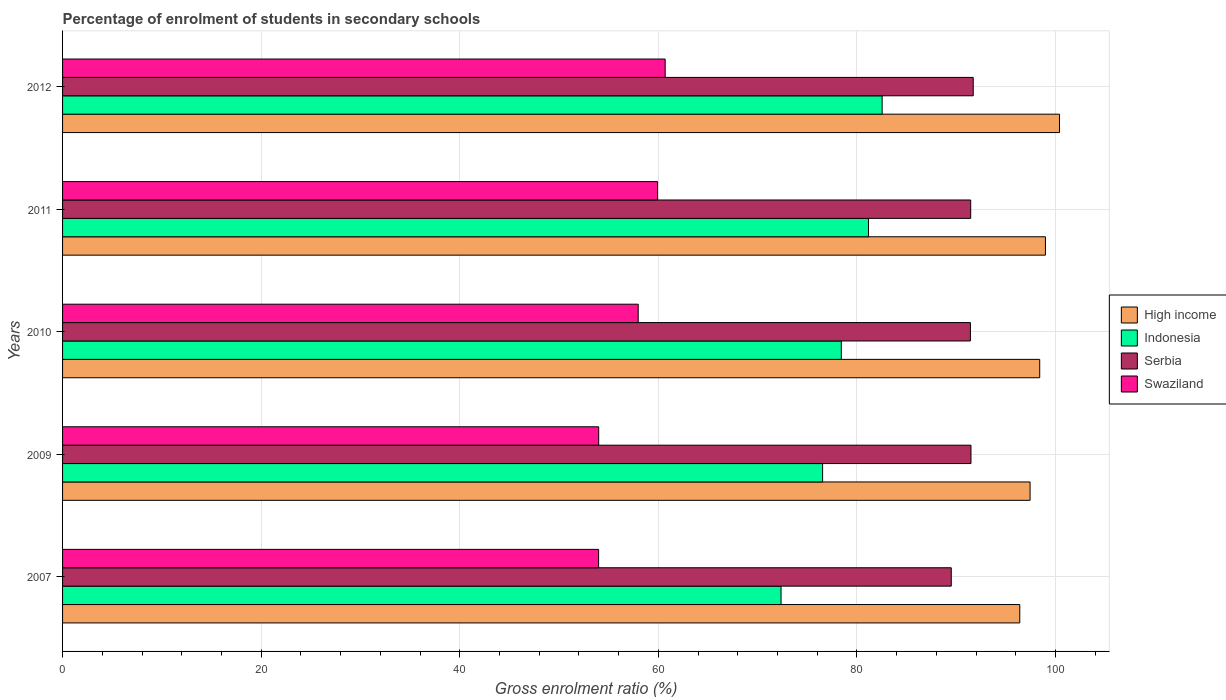How many groups of bars are there?
Keep it short and to the point. 5. Are the number of bars on each tick of the Y-axis equal?
Your response must be concise. Yes. How many bars are there on the 3rd tick from the bottom?
Your answer should be compact. 4. What is the label of the 5th group of bars from the top?
Provide a succinct answer. 2007. In how many cases, is the number of bars for a given year not equal to the number of legend labels?
Offer a very short reply. 0. What is the percentage of students enrolled in secondary schools in Indonesia in 2011?
Provide a short and direct response. 81.16. Across all years, what is the maximum percentage of students enrolled in secondary schools in High income?
Ensure brevity in your answer.  100.4. Across all years, what is the minimum percentage of students enrolled in secondary schools in Serbia?
Provide a short and direct response. 89.5. In which year was the percentage of students enrolled in secondary schools in Indonesia maximum?
Your answer should be compact. 2012. In which year was the percentage of students enrolled in secondary schools in Swaziland minimum?
Offer a very short reply. 2007. What is the total percentage of students enrolled in secondary schools in Indonesia in the graph?
Provide a succinct answer. 391.03. What is the difference between the percentage of students enrolled in secondary schools in Swaziland in 2009 and that in 2010?
Keep it short and to the point. -3.98. What is the difference between the percentage of students enrolled in secondary schools in Serbia in 2010 and the percentage of students enrolled in secondary schools in Indonesia in 2007?
Your answer should be compact. 19.07. What is the average percentage of students enrolled in secondary schools in Serbia per year?
Provide a succinct answer. 91.12. In the year 2010, what is the difference between the percentage of students enrolled in secondary schools in High income and percentage of students enrolled in secondary schools in Indonesia?
Offer a very short reply. 19.98. What is the ratio of the percentage of students enrolled in secondary schools in Swaziland in 2007 to that in 2012?
Offer a very short reply. 0.89. What is the difference between the highest and the second highest percentage of students enrolled in secondary schools in Serbia?
Offer a terse response. 0.23. What is the difference between the highest and the lowest percentage of students enrolled in secondary schools in Swaziland?
Keep it short and to the point. 6.7. Is it the case that in every year, the sum of the percentage of students enrolled in secondary schools in Indonesia and percentage of students enrolled in secondary schools in Serbia is greater than the sum of percentage of students enrolled in secondary schools in Swaziland and percentage of students enrolled in secondary schools in High income?
Your answer should be compact. Yes. What does the 4th bar from the top in 2012 represents?
Your answer should be very brief. High income. What does the 3rd bar from the bottom in 2011 represents?
Keep it short and to the point. Serbia. Is it the case that in every year, the sum of the percentage of students enrolled in secondary schools in Swaziland and percentage of students enrolled in secondary schools in Serbia is greater than the percentage of students enrolled in secondary schools in Indonesia?
Give a very brief answer. Yes. What is the difference between two consecutive major ticks on the X-axis?
Your response must be concise. 20. Are the values on the major ticks of X-axis written in scientific E-notation?
Your answer should be very brief. No. Does the graph contain any zero values?
Provide a short and direct response. No. Does the graph contain grids?
Offer a very short reply. Yes. Where does the legend appear in the graph?
Provide a succinct answer. Center right. What is the title of the graph?
Provide a succinct answer. Percentage of enrolment of students in secondary schools. Does "Gabon" appear as one of the legend labels in the graph?
Your answer should be very brief. No. What is the label or title of the X-axis?
Offer a terse response. Gross enrolment ratio (%). What is the Gross enrolment ratio (%) of High income in 2007?
Make the answer very short. 96.4. What is the Gross enrolment ratio (%) in Indonesia in 2007?
Your answer should be compact. 72.36. What is the Gross enrolment ratio (%) in Serbia in 2007?
Your answer should be compact. 89.5. What is the Gross enrolment ratio (%) of Swaziland in 2007?
Your answer should be compact. 53.98. What is the Gross enrolment ratio (%) of High income in 2009?
Your response must be concise. 97.44. What is the Gross enrolment ratio (%) of Indonesia in 2009?
Keep it short and to the point. 76.54. What is the Gross enrolment ratio (%) of Serbia in 2009?
Offer a terse response. 91.48. What is the Gross enrolment ratio (%) of Swaziland in 2009?
Provide a succinct answer. 53.99. What is the Gross enrolment ratio (%) of High income in 2010?
Ensure brevity in your answer.  98.41. What is the Gross enrolment ratio (%) in Indonesia in 2010?
Keep it short and to the point. 78.43. What is the Gross enrolment ratio (%) in Serbia in 2010?
Give a very brief answer. 91.43. What is the Gross enrolment ratio (%) of Swaziland in 2010?
Your answer should be compact. 57.97. What is the Gross enrolment ratio (%) in High income in 2011?
Keep it short and to the point. 98.98. What is the Gross enrolment ratio (%) in Indonesia in 2011?
Ensure brevity in your answer.  81.16. What is the Gross enrolment ratio (%) of Serbia in 2011?
Keep it short and to the point. 91.46. What is the Gross enrolment ratio (%) of Swaziland in 2011?
Provide a short and direct response. 59.92. What is the Gross enrolment ratio (%) of High income in 2012?
Your answer should be compact. 100.4. What is the Gross enrolment ratio (%) in Indonesia in 2012?
Your response must be concise. 82.54. What is the Gross enrolment ratio (%) in Serbia in 2012?
Make the answer very short. 91.71. What is the Gross enrolment ratio (%) in Swaziland in 2012?
Give a very brief answer. 60.69. Across all years, what is the maximum Gross enrolment ratio (%) of High income?
Your response must be concise. 100.4. Across all years, what is the maximum Gross enrolment ratio (%) of Indonesia?
Offer a very short reply. 82.54. Across all years, what is the maximum Gross enrolment ratio (%) in Serbia?
Make the answer very short. 91.71. Across all years, what is the maximum Gross enrolment ratio (%) of Swaziland?
Ensure brevity in your answer.  60.69. Across all years, what is the minimum Gross enrolment ratio (%) in High income?
Ensure brevity in your answer.  96.4. Across all years, what is the minimum Gross enrolment ratio (%) of Indonesia?
Your response must be concise. 72.36. Across all years, what is the minimum Gross enrolment ratio (%) of Serbia?
Offer a very short reply. 89.5. Across all years, what is the minimum Gross enrolment ratio (%) in Swaziland?
Give a very brief answer. 53.98. What is the total Gross enrolment ratio (%) of High income in the graph?
Offer a terse response. 491.63. What is the total Gross enrolment ratio (%) in Indonesia in the graph?
Offer a very short reply. 391.03. What is the total Gross enrolment ratio (%) in Serbia in the graph?
Offer a very short reply. 455.58. What is the total Gross enrolment ratio (%) in Swaziland in the graph?
Make the answer very short. 286.56. What is the difference between the Gross enrolment ratio (%) of High income in 2007 and that in 2009?
Make the answer very short. -1.04. What is the difference between the Gross enrolment ratio (%) in Indonesia in 2007 and that in 2009?
Your response must be concise. -4.19. What is the difference between the Gross enrolment ratio (%) of Serbia in 2007 and that in 2009?
Provide a succinct answer. -1.98. What is the difference between the Gross enrolment ratio (%) of Swaziland in 2007 and that in 2009?
Keep it short and to the point. -0.01. What is the difference between the Gross enrolment ratio (%) of High income in 2007 and that in 2010?
Keep it short and to the point. -2.01. What is the difference between the Gross enrolment ratio (%) in Indonesia in 2007 and that in 2010?
Provide a short and direct response. -6.07. What is the difference between the Gross enrolment ratio (%) in Serbia in 2007 and that in 2010?
Offer a terse response. -1.93. What is the difference between the Gross enrolment ratio (%) in Swaziland in 2007 and that in 2010?
Keep it short and to the point. -3.99. What is the difference between the Gross enrolment ratio (%) of High income in 2007 and that in 2011?
Keep it short and to the point. -2.59. What is the difference between the Gross enrolment ratio (%) in Indonesia in 2007 and that in 2011?
Offer a very short reply. -8.8. What is the difference between the Gross enrolment ratio (%) in Serbia in 2007 and that in 2011?
Make the answer very short. -1.96. What is the difference between the Gross enrolment ratio (%) of Swaziland in 2007 and that in 2011?
Your answer should be compact. -5.94. What is the difference between the Gross enrolment ratio (%) of High income in 2007 and that in 2012?
Offer a very short reply. -4. What is the difference between the Gross enrolment ratio (%) of Indonesia in 2007 and that in 2012?
Offer a very short reply. -10.18. What is the difference between the Gross enrolment ratio (%) in Serbia in 2007 and that in 2012?
Your response must be concise. -2.21. What is the difference between the Gross enrolment ratio (%) in Swaziland in 2007 and that in 2012?
Keep it short and to the point. -6.7. What is the difference between the Gross enrolment ratio (%) in High income in 2009 and that in 2010?
Give a very brief answer. -0.97. What is the difference between the Gross enrolment ratio (%) of Indonesia in 2009 and that in 2010?
Your response must be concise. -1.88. What is the difference between the Gross enrolment ratio (%) of Serbia in 2009 and that in 2010?
Your answer should be very brief. 0.06. What is the difference between the Gross enrolment ratio (%) of Swaziland in 2009 and that in 2010?
Your response must be concise. -3.98. What is the difference between the Gross enrolment ratio (%) in High income in 2009 and that in 2011?
Your response must be concise. -1.55. What is the difference between the Gross enrolment ratio (%) of Indonesia in 2009 and that in 2011?
Provide a succinct answer. -4.62. What is the difference between the Gross enrolment ratio (%) of Serbia in 2009 and that in 2011?
Give a very brief answer. 0.03. What is the difference between the Gross enrolment ratio (%) in Swaziland in 2009 and that in 2011?
Make the answer very short. -5.93. What is the difference between the Gross enrolment ratio (%) of High income in 2009 and that in 2012?
Your response must be concise. -2.96. What is the difference between the Gross enrolment ratio (%) in Indonesia in 2009 and that in 2012?
Ensure brevity in your answer.  -6. What is the difference between the Gross enrolment ratio (%) of Serbia in 2009 and that in 2012?
Make the answer very short. -0.23. What is the difference between the Gross enrolment ratio (%) of Swaziland in 2009 and that in 2012?
Give a very brief answer. -6.7. What is the difference between the Gross enrolment ratio (%) of High income in 2010 and that in 2011?
Provide a succinct answer. -0.58. What is the difference between the Gross enrolment ratio (%) of Indonesia in 2010 and that in 2011?
Offer a terse response. -2.74. What is the difference between the Gross enrolment ratio (%) in Serbia in 2010 and that in 2011?
Offer a very short reply. -0.03. What is the difference between the Gross enrolment ratio (%) of Swaziland in 2010 and that in 2011?
Give a very brief answer. -1.95. What is the difference between the Gross enrolment ratio (%) of High income in 2010 and that in 2012?
Offer a terse response. -1.99. What is the difference between the Gross enrolment ratio (%) of Indonesia in 2010 and that in 2012?
Make the answer very short. -4.11. What is the difference between the Gross enrolment ratio (%) in Serbia in 2010 and that in 2012?
Your answer should be compact. -0.28. What is the difference between the Gross enrolment ratio (%) of Swaziland in 2010 and that in 2012?
Make the answer very short. -2.71. What is the difference between the Gross enrolment ratio (%) of High income in 2011 and that in 2012?
Offer a terse response. -1.41. What is the difference between the Gross enrolment ratio (%) in Indonesia in 2011 and that in 2012?
Give a very brief answer. -1.38. What is the difference between the Gross enrolment ratio (%) of Serbia in 2011 and that in 2012?
Give a very brief answer. -0.26. What is the difference between the Gross enrolment ratio (%) in Swaziland in 2011 and that in 2012?
Offer a very short reply. -0.77. What is the difference between the Gross enrolment ratio (%) of High income in 2007 and the Gross enrolment ratio (%) of Indonesia in 2009?
Make the answer very short. 19.86. What is the difference between the Gross enrolment ratio (%) in High income in 2007 and the Gross enrolment ratio (%) in Serbia in 2009?
Your response must be concise. 4.91. What is the difference between the Gross enrolment ratio (%) of High income in 2007 and the Gross enrolment ratio (%) of Swaziland in 2009?
Offer a very short reply. 42.41. What is the difference between the Gross enrolment ratio (%) of Indonesia in 2007 and the Gross enrolment ratio (%) of Serbia in 2009?
Keep it short and to the point. -19.13. What is the difference between the Gross enrolment ratio (%) in Indonesia in 2007 and the Gross enrolment ratio (%) in Swaziland in 2009?
Give a very brief answer. 18.37. What is the difference between the Gross enrolment ratio (%) of Serbia in 2007 and the Gross enrolment ratio (%) of Swaziland in 2009?
Your response must be concise. 35.51. What is the difference between the Gross enrolment ratio (%) of High income in 2007 and the Gross enrolment ratio (%) of Indonesia in 2010?
Your response must be concise. 17.97. What is the difference between the Gross enrolment ratio (%) of High income in 2007 and the Gross enrolment ratio (%) of Serbia in 2010?
Provide a succinct answer. 4.97. What is the difference between the Gross enrolment ratio (%) in High income in 2007 and the Gross enrolment ratio (%) in Swaziland in 2010?
Offer a very short reply. 38.43. What is the difference between the Gross enrolment ratio (%) in Indonesia in 2007 and the Gross enrolment ratio (%) in Serbia in 2010?
Provide a short and direct response. -19.07. What is the difference between the Gross enrolment ratio (%) in Indonesia in 2007 and the Gross enrolment ratio (%) in Swaziland in 2010?
Your response must be concise. 14.38. What is the difference between the Gross enrolment ratio (%) in Serbia in 2007 and the Gross enrolment ratio (%) in Swaziland in 2010?
Provide a succinct answer. 31.53. What is the difference between the Gross enrolment ratio (%) in High income in 2007 and the Gross enrolment ratio (%) in Indonesia in 2011?
Your answer should be very brief. 15.24. What is the difference between the Gross enrolment ratio (%) in High income in 2007 and the Gross enrolment ratio (%) in Serbia in 2011?
Your answer should be compact. 4.94. What is the difference between the Gross enrolment ratio (%) of High income in 2007 and the Gross enrolment ratio (%) of Swaziland in 2011?
Provide a short and direct response. 36.48. What is the difference between the Gross enrolment ratio (%) of Indonesia in 2007 and the Gross enrolment ratio (%) of Serbia in 2011?
Ensure brevity in your answer.  -19.1. What is the difference between the Gross enrolment ratio (%) of Indonesia in 2007 and the Gross enrolment ratio (%) of Swaziland in 2011?
Your answer should be very brief. 12.44. What is the difference between the Gross enrolment ratio (%) in Serbia in 2007 and the Gross enrolment ratio (%) in Swaziland in 2011?
Provide a short and direct response. 29.58. What is the difference between the Gross enrolment ratio (%) in High income in 2007 and the Gross enrolment ratio (%) in Indonesia in 2012?
Provide a short and direct response. 13.86. What is the difference between the Gross enrolment ratio (%) of High income in 2007 and the Gross enrolment ratio (%) of Serbia in 2012?
Provide a short and direct response. 4.69. What is the difference between the Gross enrolment ratio (%) of High income in 2007 and the Gross enrolment ratio (%) of Swaziland in 2012?
Give a very brief answer. 35.71. What is the difference between the Gross enrolment ratio (%) in Indonesia in 2007 and the Gross enrolment ratio (%) in Serbia in 2012?
Make the answer very short. -19.35. What is the difference between the Gross enrolment ratio (%) in Indonesia in 2007 and the Gross enrolment ratio (%) in Swaziland in 2012?
Offer a very short reply. 11.67. What is the difference between the Gross enrolment ratio (%) of Serbia in 2007 and the Gross enrolment ratio (%) of Swaziland in 2012?
Provide a short and direct response. 28.81. What is the difference between the Gross enrolment ratio (%) in High income in 2009 and the Gross enrolment ratio (%) in Indonesia in 2010?
Your answer should be compact. 19.01. What is the difference between the Gross enrolment ratio (%) of High income in 2009 and the Gross enrolment ratio (%) of Serbia in 2010?
Your answer should be compact. 6.01. What is the difference between the Gross enrolment ratio (%) in High income in 2009 and the Gross enrolment ratio (%) in Swaziland in 2010?
Make the answer very short. 39.46. What is the difference between the Gross enrolment ratio (%) in Indonesia in 2009 and the Gross enrolment ratio (%) in Serbia in 2010?
Your response must be concise. -14.88. What is the difference between the Gross enrolment ratio (%) in Indonesia in 2009 and the Gross enrolment ratio (%) in Swaziland in 2010?
Keep it short and to the point. 18.57. What is the difference between the Gross enrolment ratio (%) of Serbia in 2009 and the Gross enrolment ratio (%) of Swaziland in 2010?
Your response must be concise. 33.51. What is the difference between the Gross enrolment ratio (%) in High income in 2009 and the Gross enrolment ratio (%) in Indonesia in 2011?
Offer a very short reply. 16.27. What is the difference between the Gross enrolment ratio (%) in High income in 2009 and the Gross enrolment ratio (%) in Serbia in 2011?
Offer a very short reply. 5.98. What is the difference between the Gross enrolment ratio (%) of High income in 2009 and the Gross enrolment ratio (%) of Swaziland in 2011?
Give a very brief answer. 37.52. What is the difference between the Gross enrolment ratio (%) in Indonesia in 2009 and the Gross enrolment ratio (%) in Serbia in 2011?
Offer a very short reply. -14.91. What is the difference between the Gross enrolment ratio (%) of Indonesia in 2009 and the Gross enrolment ratio (%) of Swaziland in 2011?
Keep it short and to the point. 16.62. What is the difference between the Gross enrolment ratio (%) in Serbia in 2009 and the Gross enrolment ratio (%) in Swaziland in 2011?
Keep it short and to the point. 31.56. What is the difference between the Gross enrolment ratio (%) of High income in 2009 and the Gross enrolment ratio (%) of Indonesia in 2012?
Provide a succinct answer. 14.9. What is the difference between the Gross enrolment ratio (%) of High income in 2009 and the Gross enrolment ratio (%) of Serbia in 2012?
Make the answer very short. 5.72. What is the difference between the Gross enrolment ratio (%) of High income in 2009 and the Gross enrolment ratio (%) of Swaziland in 2012?
Your answer should be compact. 36.75. What is the difference between the Gross enrolment ratio (%) of Indonesia in 2009 and the Gross enrolment ratio (%) of Serbia in 2012?
Your answer should be compact. -15.17. What is the difference between the Gross enrolment ratio (%) of Indonesia in 2009 and the Gross enrolment ratio (%) of Swaziland in 2012?
Ensure brevity in your answer.  15.86. What is the difference between the Gross enrolment ratio (%) in Serbia in 2009 and the Gross enrolment ratio (%) in Swaziland in 2012?
Keep it short and to the point. 30.8. What is the difference between the Gross enrolment ratio (%) in High income in 2010 and the Gross enrolment ratio (%) in Indonesia in 2011?
Offer a very short reply. 17.24. What is the difference between the Gross enrolment ratio (%) of High income in 2010 and the Gross enrolment ratio (%) of Serbia in 2011?
Offer a very short reply. 6.95. What is the difference between the Gross enrolment ratio (%) in High income in 2010 and the Gross enrolment ratio (%) in Swaziland in 2011?
Give a very brief answer. 38.49. What is the difference between the Gross enrolment ratio (%) of Indonesia in 2010 and the Gross enrolment ratio (%) of Serbia in 2011?
Ensure brevity in your answer.  -13.03. What is the difference between the Gross enrolment ratio (%) in Indonesia in 2010 and the Gross enrolment ratio (%) in Swaziland in 2011?
Your answer should be very brief. 18.51. What is the difference between the Gross enrolment ratio (%) of Serbia in 2010 and the Gross enrolment ratio (%) of Swaziland in 2011?
Provide a short and direct response. 31.51. What is the difference between the Gross enrolment ratio (%) in High income in 2010 and the Gross enrolment ratio (%) in Indonesia in 2012?
Offer a terse response. 15.87. What is the difference between the Gross enrolment ratio (%) in High income in 2010 and the Gross enrolment ratio (%) in Serbia in 2012?
Make the answer very short. 6.7. What is the difference between the Gross enrolment ratio (%) in High income in 2010 and the Gross enrolment ratio (%) in Swaziland in 2012?
Make the answer very short. 37.72. What is the difference between the Gross enrolment ratio (%) of Indonesia in 2010 and the Gross enrolment ratio (%) of Serbia in 2012?
Offer a terse response. -13.29. What is the difference between the Gross enrolment ratio (%) in Indonesia in 2010 and the Gross enrolment ratio (%) in Swaziland in 2012?
Offer a very short reply. 17.74. What is the difference between the Gross enrolment ratio (%) in Serbia in 2010 and the Gross enrolment ratio (%) in Swaziland in 2012?
Make the answer very short. 30.74. What is the difference between the Gross enrolment ratio (%) in High income in 2011 and the Gross enrolment ratio (%) in Indonesia in 2012?
Give a very brief answer. 16.45. What is the difference between the Gross enrolment ratio (%) in High income in 2011 and the Gross enrolment ratio (%) in Serbia in 2012?
Your answer should be compact. 7.27. What is the difference between the Gross enrolment ratio (%) of High income in 2011 and the Gross enrolment ratio (%) of Swaziland in 2012?
Offer a terse response. 38.3. What is the difference between the Gross enrolment ratio (%) in Indonesia in 2011 and the Gross enrolment ratio (%) in Serbia in 2012?
Offer a terse response. -10.55. What is the difference between the Gross enrolment ratio (%) of Indonesia in 2011 and the Gross enrolment ratio (%) of Swaziland in 2012?
Your response must be concise. 20.48. What is the difference between the Gross enrolment ratio (%) in Serbia in 2011 and the Gross enrolment ratio (%) in Swaziland in 2012?
Provide a short and direct response. 30.77. What is the average Gross enrolment ratio (%) of High income per year?
Your answer should be very brief. 98.33. What is the average Gross enrolment ratio (%) of Indonesia per year?
Provide a short and direct response. 78.21. What is the average Gross enrolment ratio (%) in Serbia per year?
Ensure brevity in your answer.  91.12. What is the average Gross enrolment ratio (%) in Swaziland per year?
Provide a succinct answer. 57.31. In the year 2007, what is the difference between the Gross enrolment ratio (%) in High income and Gross enrolment ratio (%) in Indonesia?
Keep it short and to the point. 24.04. In the year 2007, what is the difference between the Gross enrolment ratio (%) of High income and Gross enrolment ratio (%) of Serbia?
Offer a very short reply. 6.9. In the year 2007, what is the difference between the Gross enrolment ratio (%) in High income and Gross enrolment ratio (%) in Swaziland?
Your response must be concise. 42.41. In the year 2007, what is the difference between the Gross enrolment ratio (%) in Indonesia and Gross enrolment ratio (%) in Serbia?
Give a very brief answer. -17.14. In the year 2007, what is the difference between the Gross enrolment ratio (%) of Indonesia and Gross enrolment ratio (%) of Swaziland?
Provide a short and direct response. 18.37. In the year 2007, what is the difference between the Gross enrolment ratio (%) in Serbia and Gross enrolment ratio (%) in Swaziland?
Ensure brevity in your answer.  35.52. In the year 2009, what is the difference between the Gross enrolment ratio (%) of High income and Gross enrolment ratio (%) of Indonesia?
Your answer should be compact. 20.89. In the year 2009, what is the difference between the Gross enrolment ratio (%) of High income and Gross enrolment ratio (%) of Serbia?
Provide a succinct answer. 5.95. In the year 2009, what is the difference between the Gross enrolment ratio (%) of High income and Gross enrolment ratio (%) of Swaziland?
Offer a terse response. 43.45. In the year 2009, what is the difference between the Gross enrolment ratio (%) in Indonesia and Gross enrolment ratio (%) in Serbia?
Offer a terse response. -14.94. In the year 2009, what is the difference between the Gross enrolment ratio (%) of Indonesia and Gross enrolment ratio (%) of Swaziland?
Your answer should be compact. 22.55. In the year 2009, what is the difference between the Gross enrolment ratio (%) in Serbia and Gross enrolment ratio (%) in Swaziland?
Ensure brevity in your answer.  37.49. In the year 2010, what is the difference between the Gross enrolment ratio (%) in High income and Gross enrolment ratio (%) in Indonesia?
Offer a very short reply. 19.98. In the year 2010, what is the difference between the Gross enrolment ratio (%) of High income and Gross enrolment ratio (%) of Serbia?
Your answer should be compact. 6.98. In the year 2010, what is the difference between the Gross enrolment ratio (%) of High income and Gross enrolment ratio (%) of Swaziland?
Your answer should be very brief. 40.43. In the year 2010, what is the difference between the Gross enrolment ratio (%) in Indonesia and Gross enrolment ratio (%) in Serbia?
Offer a terse response. -13. In the year 2010, what is the difference between the Gross enrolment ratio (%) in Indonesia and Gross enrolment ratio (%) in Swaziland?
Your answer should be very brief. 20.45. In the year 2010, what is the difference between the Gross enrolment ratio (%) in Serbia and Gross enrolment ratio (%) in Swaziland?
Provide a succinct answer. 33.45. In the year 2011, what is the difference between the Gross enrolment ratio (%) in High income and Gross enrolment ratio (%) in Indonesia?
Offer a terse response. 17.82. In the year 2011, what is the difference between the Gross enrolment ratio (%) in High income and Gross enrolment ratio (%) in Serbia?
Your answer should be very brief. 7.53. In the year 2011, what is the difference between the Gross enrolment ratio (%) in High income and Gross enrolment ratio (%) in Swaziland?
Offer a very short reply. 39.06. In the year 2011, what is the difference between the Gross enrolment ratio (%) of Indonesia and Gross enrolment ratio (%) of Serbia?
Provide a succinct answer. -10.29. In the year 2011, what is the difference between the Gross enrolment ratio (%) in Indonesia and Gross enrolment ratio (%) in Swaziland?
Your response must be concise. 21.24. In the year 2011, what is the difference between the Gross enrolment ratio (%) of Serbia and Gross enrolment ratio (%) of Swaziland?
Offer a terse response. 31.54. In the year 2012, what is the difference between the Gross enrolment ratio (%) of High income and Gross enrolment ratio (%) of Indonesia?
Provide a succinct answer. 17.86. In the year 2012, what is the difference between the Gross enrolment ratio (%) of High income and Gross enrolment ratio (%) of Serbia?
Offer a terse response. 8.69. In the year 2012, what is the difference between the Gross enrolment ratio (%) in High income and Gross enrolment ratio (%) in Swaziland?
Your answer should be compact. 39.71. In the year 2012, what is the difference between the Gross enrolment ratio (%) of Indonesia and Gross enrolment ratio (%) of Serbia?
Keep it short and to the point. -9.17. In the year 2012, what is the difference between the Gross enrolment ratio (%) of Indonesia and Gross enrolment ratio (%) of Swaziland?
Provide a short and direct response. 21.85. In the year 2012, what is the difference between the Gross enrolment ratio (%) of Serbia and Gross enrolment ratio (%) of Swaziland?
Offer a terse response. 31.02. What is the ratio of the Gross enrolment ratio (%) of High income in 2007 to that in 2009?
Keep it short and to the point. 0.99. What is the ratio of the Gross enrolment ratio (%) in Indonesia in 2007 to that in 2009?
Give a very brief answer. 0.95. What is the ratio of the Gross enrolment ratio (%) in Serbia in 2007 to that in 2009?
Your answer should be very brief. 0.98. What is the ratio of the Gross enrolment ratio (%) in Swaziland in 2007 to that in 2009?
Keep it short and to the point. 1. What is the ratio of the Gross enrolment ratio (%) of High income in 2007 to that in 2010?
Keep it short and to the point. 0.98. What is the ratio of the Gross enrolment ratio (%) in Indonesia in 2007 to that in 2010?
Keep it short and to the point. 0.92. What is the ratio of the Gross enrolment ratio (%) of Serbia in 2007 to that in 2010?
Offer a very short reply. 0.98. What is the ratio of the Gross enrolment ratio (%) in Swaziland in 2007 to that in 2010?
Keep it short and to the point. 0.93. What is the ratio of the Gross enrolment ratio (%) in High income in 2007 to that in 2011?
Your response must be concise. 0.97. What is the ratio of the Gross enrolment ratio (%) of Indonesia in 2007 to that in 2011?
Give a very brief answer. 0.89. What is the ratio of the Gross enrolment ratio (%) of Serbia in 2007 to that in 2011?
Provide a short and direct response. 0.98. What is the ratio of the Gross enrolment ratio (%) of Swaziland in 2007 to that in 2011?
Your response must be concise. 0.9. What is the ratio of the Gross enrolment ratio (%) in High income in 2007 to that in 2012?
Keep it short and to the point. 0.96. What is the ratio of the Gross enrolment ratio (%) in Indonesia in 2007 to that in 2012?
Your answer should be compact. 0.88. What is the ratio of the Gross enrolment ratio (%) of Serbia in 2007 to that in 2012?
Provide a short and direct response. 0.98. What is the ratio of the Gross enrolment ratio (%) in Swaziland in 2007 to that in 2012?
Provide a succinct answer. 0.89. What is the ratio of the Gross enrolment ratio (%) in Indonesia in 2009 to that in 2010?
Keep it short and to the point. 0.98. What is the ratio of the Gross enrolment ratio (%) in Serbia in 2009 to that in 2010?
Your answer should be compact. 1. What is the ratio of the Gross enrolment ratio (%) in Swaziland in 2009 to that in 2010?
Provide a short and direct response. 0.93. What is the ratio of the Gross enrolment ratio (%) of High income in 2009 to that in 2011?
Offer a terse response. 0.98. What is the ratio of the Gross enrolment ratio (%) in Indonesia in 2009 to that in 2011?
Ensure brevity in your answer.  0.94. What is the ratio of the Gross enrolment ratio (%) in Swaziland in 2009 to that in 2011?
Provide a succinct answer. 0.9. What is the ratio of the Gross enrolment ratio (%) of High income in 2009 to that in 2012?
Provide a short and direct response. 0.97. What is the ratio of the Gross enrolment ratio (%) in Indonesia in 2009 to that in 2012?
Your answer should be very brief. 0.93. What is the ratio of the Gross enrolment ratio (%) in Swaziland in 2009 to that in 2012?
Your response must be concise. 0.89. What is the ratio of the Gross enrolment ratio (%) in Indonesia in 2010 to that in 2011?
Your response must be concise. 0.97. What is the ratio of the Gross enrolment ratio (%) of Swaziland in 2010 to that in 2011?
Make the answer very short. 0.97. What is the ratio of the Gross enrolment ratio (%) of High income in 2010 to that in 2012?
Make the answer very short. 0.98. What is the ratio of the Gross enrolment ratio (%) in Indonesia in 2010 to that in 2012?
Offer a very short reply. 0.95. What is the ratio of the Gross enrolment ratio (%) in Swaziland in 2010 to that in 2012?
Your answer should be very brief. 0.96. What is the ratio of the Gross enrolment ratio (%) of High income in 2011 to that in 2012?
Give a very brief answer. 0.99. What is the ratio of the Gross enrolment ratio (%) of Indonesia in 2011 to that in 2012?
Ensure brevity in your answer.  0.98. What is the ratio of the Gross enrolment ratio (%) in Swaziland in 2011 to that in 2012?
Give a very brief answer. 0.99. What is the difference between the highest and the second highest Gross enrolment ratio (%) of High income?
Make the answer very short. 1.41. What is the difference between the highest and the second highest Gross enrolment ratio (%) of Indonesia?
Your answer should be very brief. 1.38. What is the difference between the highest and the second highest Gross enrolment ratio (%) of Serbia?
Ensure brevity in your answer.  0.23. What is the difference between the highest and the second highest Gross enrolment ratio (%) in Swaziland?
Give a very brief answer. 0.77. What is the difference between the highest and the lowest Gross enrolment ratio (%) of High income?
Your response must be concise. 4. What is the difference between the highest and the lowest Gross enrolment ratio (%) in Indonesia?
Make the answer very short. 10.18. What is the difference between the highest and the lowest Gross enrolment ratio (%) of Serbia?
Offer a very short reply. 2.21. What is the difference between the highest and the lowest Gross enrolment ratio (%) of Swaziland?
Keep it short and to the point. 6.7. 